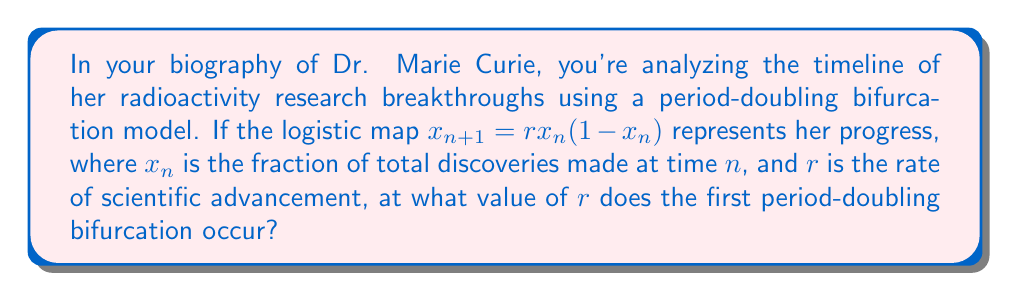Provide a solution to this math problem. To find the first period-doubling bifurcation in the logistic map, we need to follow these steps:

1) The logistic map is given by $x_{n+1} = rx_n(1-x_n)$.

2) At equilibrium, $x_{n+1} = x_n = x^*$. So, we can write:
   $x^* = rx^*(1-x^*)$

3) Solving this equation:
   $x^* = rx^* - rx^{*2}$
   $rx^{*2} - (r-1)x^* = 0$
   $x^*(rx^* - (r-1)) = 0$

4) This gives us two solutions:
   $x^* = 0$ or $x^* = \frac{r-1}{r}$

5) The non-zero solution $x^* = \frac{r-1}{r}$ is stable when $|-2x^*+1| < 1$

6) Substituting our solution:
   $|-2(\frac{r-1}{r})+1| < 1$
   $|-\frac{2r-2}{r}+1| < 1$
   $|-\frac{2r-2+r}{r}| < 1$
   $|-\frac{3r-2}{r}| < 1$

7) Solving this inequality:
   $-1 < -\frac{3r-2}{r} < 1$
   $-r < -3r+2 < r$
   $r < 3r-2 < 3r$
   $1 < r < 3$

8) The first period-doubling bifurcation occurs when the stability condition is no longer met, i.e., when $r = 3$.
Answer: 3 